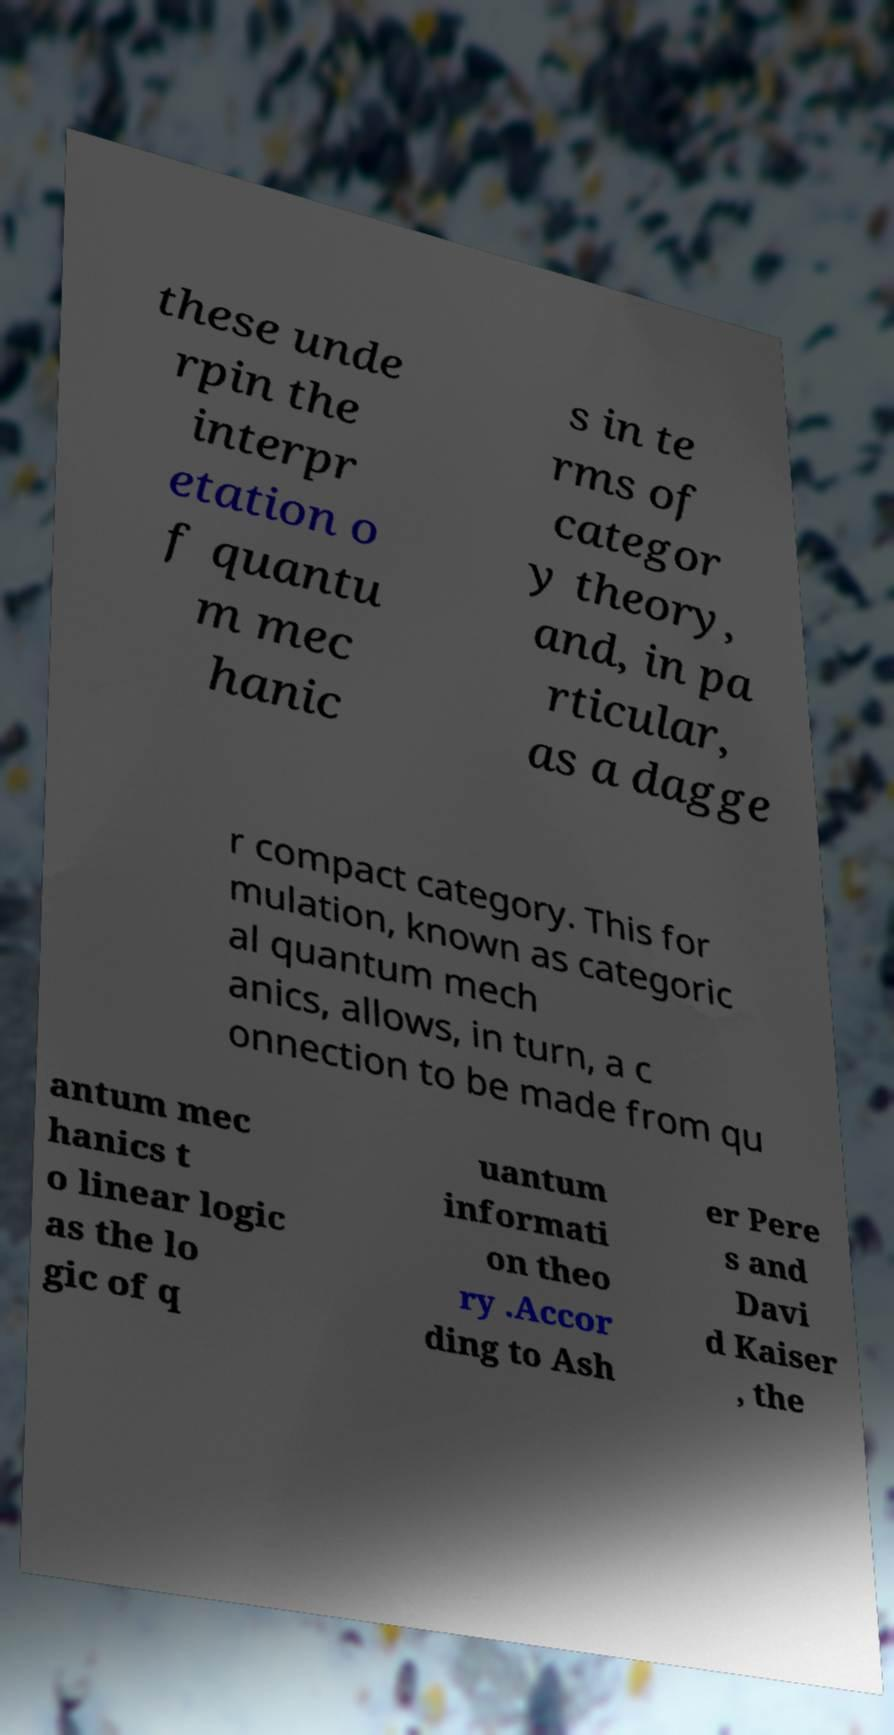Please identify and transcribe the text found in this image. these unde rpin the interpr etation o f quantu m mec hanic s in te rms of categor y theory, and, in pa rticular, as a dagge r compact category. This for mulation, known as categoric al quantum mech anics, allows, in turn, a c onnection to be made from qu antum mec hanics t o linear logic as the lo gic of q uantum informati on theo ry .Accor ding to Ash er Pere s and Davi d Kaiser , the 